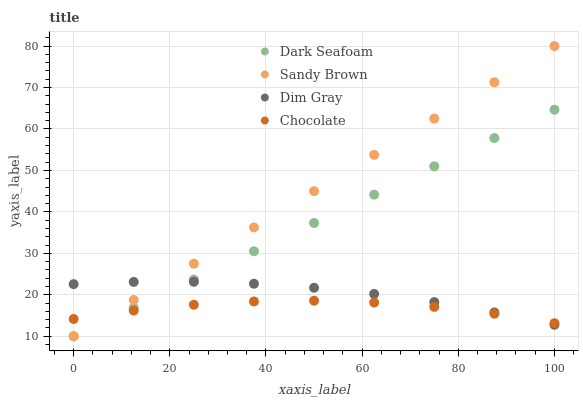Does Chocolate have the minimum area under the curve?
Answer yes or no. Yes. Does Sandy Brown have the maximum area under the curve?
Answer yes or no. Yes. Does Dim Gray have the minimum area under the curve?
Answer yes or no. No. Does Dim Gray have the maximum area under the curve?
Answer yes or no. No. Is Sandy Brown the smoothest?
Answer yes or no. Yes. Is Chocolate the roughest?
Answer yes or no. Yes. Is Dim Gray the smoothest?
Answer yes or no. No. Is Dim Gray the roughest?
Answer yes or no. No. Does Dark Seafoam have the lowest value?
Answer yes or no. Yes. Does Dim Gray have the lowest value?
Answer yes or no. No. Does Sandy Brown have the highest value?
Answer yes or no. Yes. Does Dim Gray have the highest value?
Answer yes or no. No. Does Dim Gray intersect Chocolate?
Answer yes or no. Yes. Is Dim Gray less than Chocolate?
Answer yes or no. No. Is Dim Gray greater than Chocolate?
Answer yes or no. No. 